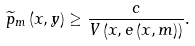Convert formula to latex. <formula><loc_0><loc_0><loc_500><loc_500>\widetilde { p } _ { m } \left ( x , y \right ) \geq \frac { c } { V \left ( x , e \left ( x , m \right ) \right ) } .</formula> 